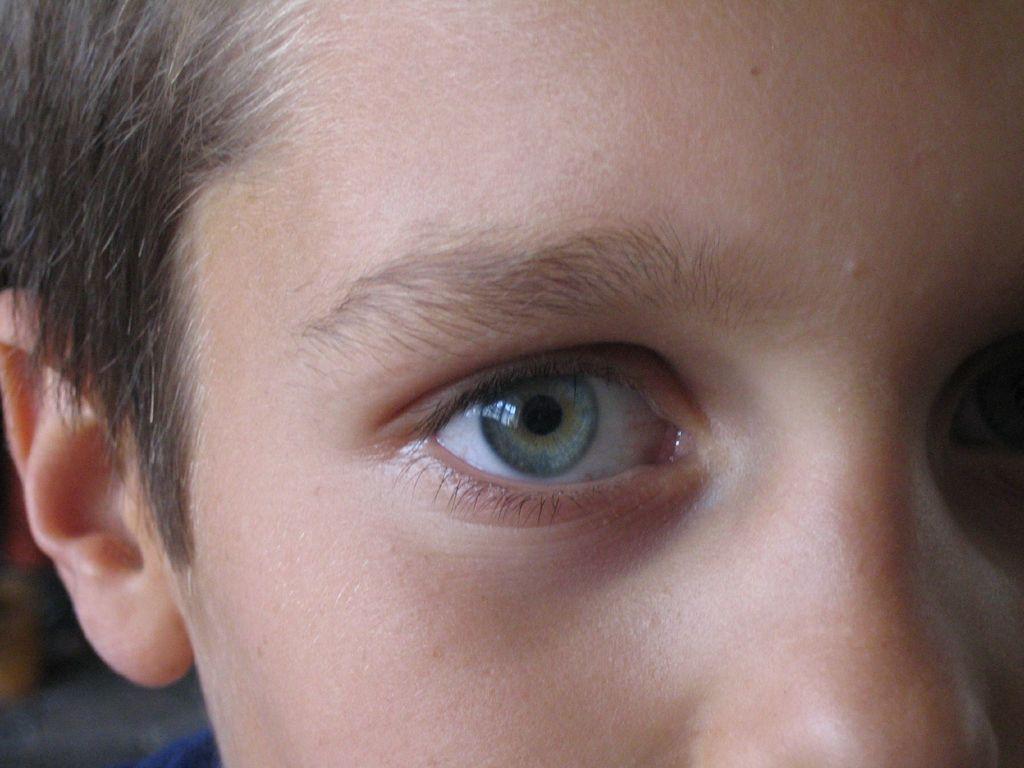Describe this image in one or two sentences. In this image I can see a person's face and some objects. This image is taken may be in a room. 